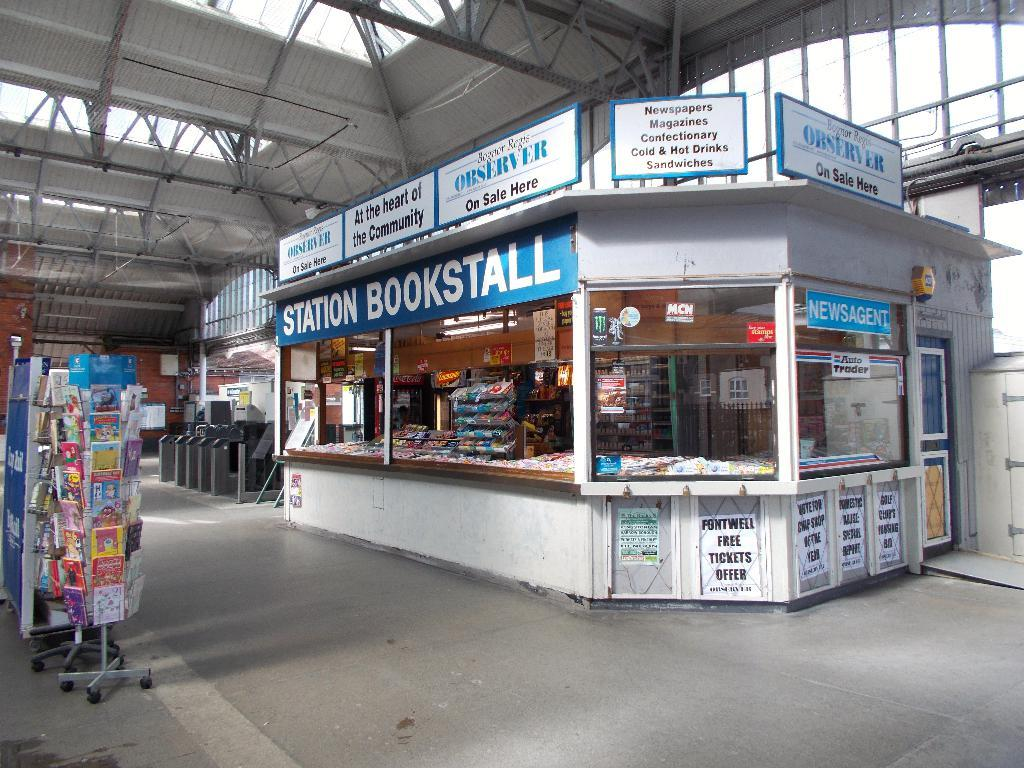<image>
Create a compact narrative representing the image presented. A sign at the Station Bookstall says they sell the Observer here. 